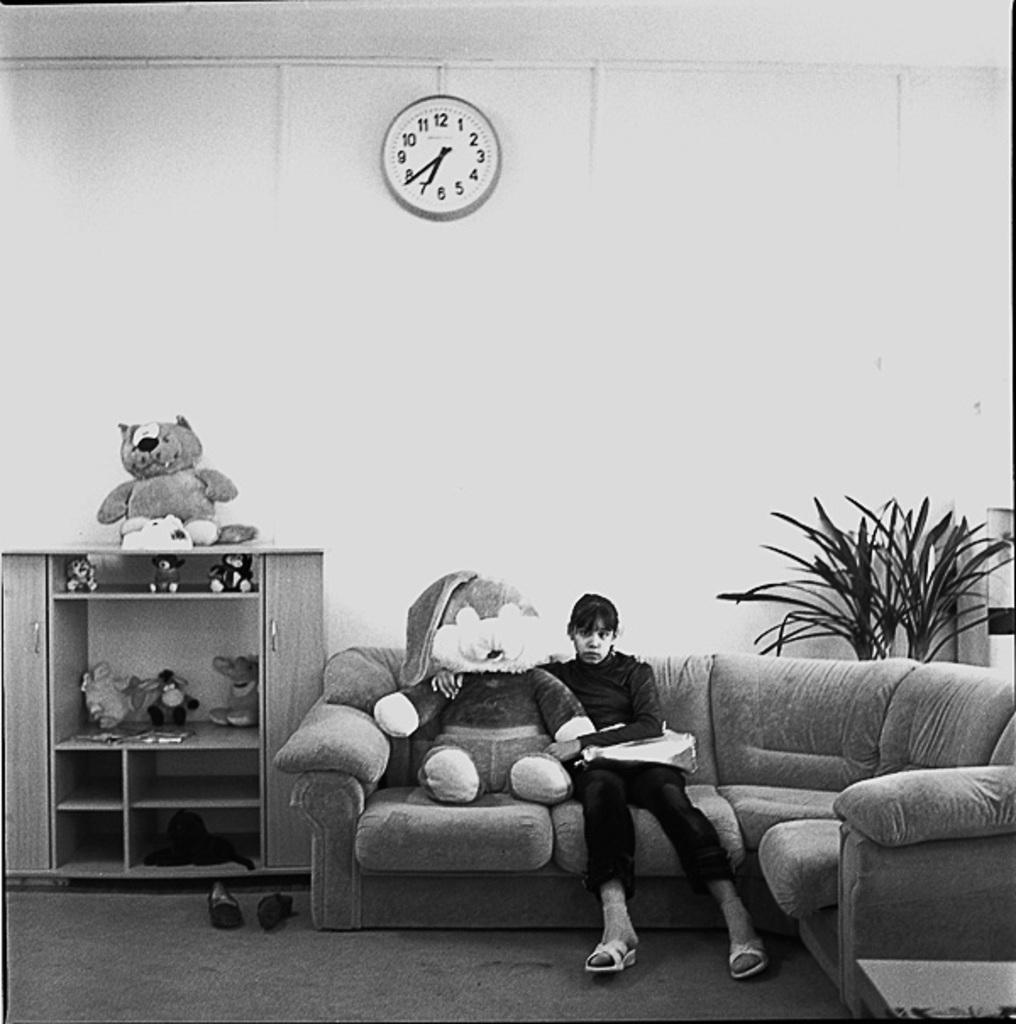Describe this image in one or two sentences. A girl is sitting in the sofa with a doll there is a wall clock at the top there are plants in the right. 